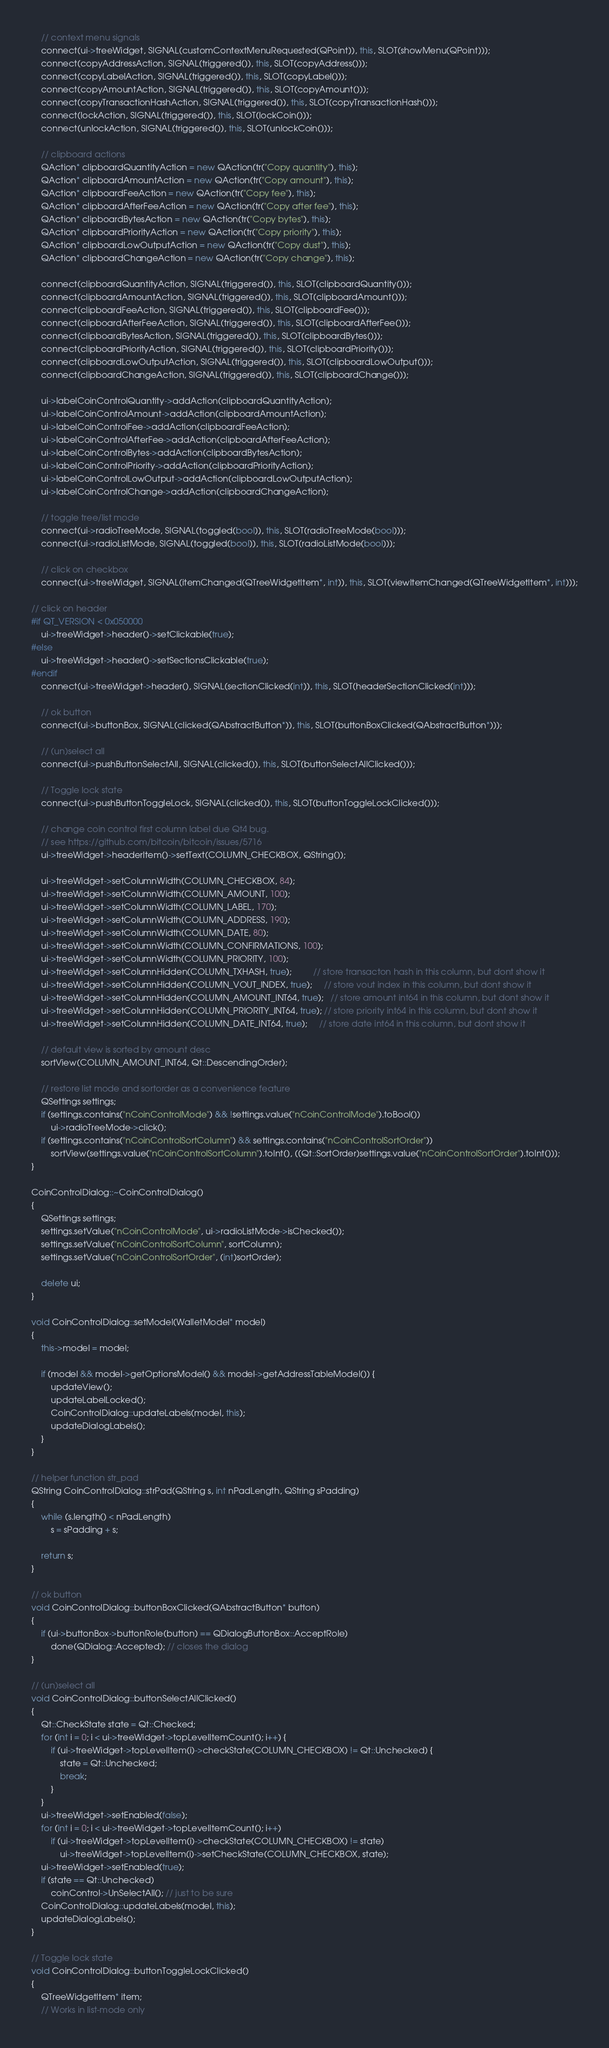Convert code to text. <code><loc_0><loc_0><loc_500><loc_500><_C++_>
    // context menu signals
    connect(ui->treeWidget, SIGNAL(customContextMenuRequested(QPoint)), this, SLOT(showMenu(QPoint)));
    connect(copyAddressAction, SIGNAL(triggered()), this, SLOT(copyAddress()));
    connect(copyLabelAction, SIGNAL(triggered()), this, SLOT(copyLabel()));
    connect(copyAmountAction, SIGNAL(triggered()), this, SLOT(copyAmount()));
    connect(copyTransactionHashAction, SIGNAL(triggered()), this, SLOT(copyTransactionHash()));
    connect(lockAction, SIGNAL(triggered()), this, SLOT(lockCoin()));
    connect(unlockAction, SIGNAL(triggered()), this, SLOT(unlockCoin()));

    // clipboard actions
    QAction* clipboardQuantityAction = new QAction(tr("Copy quantity"), this);
    QAction* clipboardAmountAction = new QAction(tr("Copy amount"), this);
    QAction* clipboardFeeAction = new QAction(tr("Copy fee"), this);
    QAction* clipboardAfterFeeAction = new QAction(tr("Copy after fee"), this);
    QAction* clipboardBytesAction = new QAction(tr("Copy bytes"), this);
    QAction* clipboardPriorityAction = new QAction(tr("Copy priority"), this);
    QAction* clipboardLowOutputAction = new QAction(tr("Copy dust"), this);
    QAction* clipboardChangeAction = new QAction(tr("Copy change"), this);

    connect(clipboardQuantityAction, SIGNAL(triggered()), this, SLOT(clipboardQuantity()));
    connect(clipboardAmountAction, SIGNAL(triggered()), this, SLOT(clipboardAmount()));
    connect(clipboardFeeAction, SIGNAL(triggered()), this, SLOT(clipboardFee()));
    connect(clipboardAfterFeeAction, SIGNAL(triggered()), this, SLOT(clipboardAfterFee()));
    connect(clipboardBytesAction, SIGNAL(triggered()), this, SLOT(clipboardBytes()));
    connect(clipboardPriorityAction, SIGNAL(triggered()), this, SLOT(clipboardPriority()));
    connect(clipboardLowOutputAction, SIGNAL(triggered()), this, SLOT(clipboardLowOutput()));
    connect(clipboardChangeAction, SIGNAL(triggered()), this, SLOT(clipboardChange()));

    ui->labelCoinControlQuantity->addAction(clipboardQuantityAction);
    ui->labelCoinControlAmount->addAction(clipboardAmountAction);
    ui->labelCoinControlFee->addAction(clipboardFeeAction);
    ui->labelCoinControlAfterFee->addAction(clipboardAfterFeeAction);
    ui->labelCoinControlBytes->addAction(clipboardBytesAction);
    ui->labelCoinControlPriority->addAction(clipboardPriorityAction);
    ui->labelCoinControlLowOutput->addAction(clipboardLowOutputAction);
    ui->labelCoinControlChange->addAction(clipboardChangeAction);

    // toggle tree/list mode
    connect(ui->radioTreeMode, SIGNAL(toggled(bool)), this, SLOT(radioTreeMode(bool)));
    connect(ui->radioListMode, SIGNAL(toggled(bool)), this, SLOT(radioListMode(bool)));

    // click on checkbox
    connect(ui->treeWidget, SIGNAL(itemChanged(QTreeWidgetItem*, int)), this, SLOT(viewItemChanged(QTreeWidgetItem*, int)));

// click on header
#if QT_VERSION < 0x050000
    ui->treeWidget->header()->setClickable(true);
#else
    ui->treeWidget->header()->setSectionsClickable(true);
#endif
    connect(ui->treeWidget->header(), SIGNAL(sectionClicked(int)), this, SLOT(headerSectionClicked(int)));

    // ok button
    connect(ui->buttonBox, SIGNAL(clicked(QAbstractButton*)), this, SLOT(buttonBoxClicked(QAbstractButton*)));

    // (un)select all
    connect(ui->pushButtonSelectAll, SIGNAL(clicked()), this, SLOT(buttonSelectAllClicked()));

    // Toggle lock state
    connect(ui->pushButtonToggleLock, SIGNAL(clicked()), this, SLOT(buttonToggleLockClicked()));

    // change coin control first column label due Qt4 bug.
    // see https://github.com/bitcoin/bitcoin/issues/5716
    ui->treeWidget->headerItem()->setText(COLUMN_CHECKBOX, QString());

    ui->treeWidget->setColumnWidth(COLUMN_CHECKBOX, 84);
    ui->treeWidget->setColumnWidth(COLUMN_AMOUNT, 100);
    ui->treeWidget->setColumnWidth(COLUMN_LABEL, 170);
    ui->treeWidget->setColumnWidth(COLUMN_ADDRESS, 190);
    ui->treeWidget->setColumnWidth(COLUMN_DATE, 80);
    ui->treeWidget->setColumnWidth(COLUMN_CONFIRMATIONS, 100);
    ui->treeWidget->setColumnWidth(COLUMN_PRIORITY, 100);
    ui->treeWidget->setColumnHidden(COLUMN_TXHASH, true);         // store transacton hash in this column, but dont show it
    ui->treeWidget->setColumnHidden(COLUMN_VOUT_INDEX, true);     // store vout index in this column, but dont show it
    ui->treeWidget->setColumnHidden(COLUMN_AMOUNT_INT64, true);   // store amount int64 in this column, but dont show it
    ui->treeWidget->setColumnHidden(COLUMN_PRIORITY_INT64, true); // store priority int64 in this column, but dont show it
    ui->treeWidget->setColumnHidden(COLUMN_DATE_INT64, true);     // store date int64 in this column, but dont show it

    // default view is sorted by amount desc
    sortView(COLUMN_AMOUNT_INT64, Qt::DescendingOrder);

    // restore list mode and sortorder as a convenience feature
    QSettings settings;
    if (settings.contains("nCoinControlMode") && !settings.value("nCoinControlMode").toBool())
        ui->radioTreeMode->click();
    if (settings.contains("nCoinControlSortColumn") && settings.contains("nCoinControlSortOrder"))
        sortView(settings.value("nCoinControlSortColumn").toInt(), ((Qt::SortOrder)settings.value("nCoinControlSortOrder").toInt()));
}

CoinControlDialog::~CoinControlDialog()
{
    QSettings settings;
    settings.setValue("nCoinControlMode", ui->radioListMode->isChecked());
    settings.setValue("nCoinControlSortColumn", sortColumn);
    settings.setValue("nCoinControlSortOrder", (int)sortOrder);

    delete ui;
}

void CoinControlDialog::setModel(WalletModel* model)
{
    this->model = model;

    if (model && model->getOptionsModel() && model->getAddressTableModel()) {
        updateView();
        updateLabelLocked();
        CoinControlDialog::updateLabels(model, this);
        updateDialogLabels();
    }
}

// helper function str_pad
QString CoinControlDialog::strPad(QString s, int nPadLength, QString sPadding)
{
    while (s.length() < nPadLength)
        s = sPadding + s;

    return s;
}

// ok button
void CoinControlDialog::buttonBoxClicked(QAbstractButton* button)
{
    if (ui->buttonBox->buttonRole(button) == QDialogButtonBox::AcceptRole)
        done(QDialog::Accepted); // closes the dialog
}

// (un)select all
void CoinControlDialog::buttonSelectAllClicked()
{
    Qt::CheckState state = Qt::Checked;
    for (int i = 0; i < ui->treeWidget->topLevelItemCount(); i++) {
        if (ui->treeWidget->topLevelItem(i)->checkState(COLUMN_CHECKBOX) != Qt::Unchecked) {
            state = Qt::Unchecked;
            break;
        }
    }
    ui->treeWidget->setEnabled(false);
    for (int i = 0; i < ui->treeWidget->topLevelItemCount(); i++)
        if (ui->treeWidget->topLevelItem(i)->checkState(COLUMN_CHECKBOX) != state)
            ui->treeWidget->topLevelItem(i)->setCheckState(COLUMN_CHECKBOX, state);
    ui->treeWidget->setEnabled(true);
    if (state == Qt::Unchecked)
        coinControl->UnSelectAll(); // just to be sure
    CoinControlDialog::updateLabels(model, this);
    updateDialogLabels();
}

// Toggle lock state
void CoinControlDialog::buttonToggleLockClicked()
{
    QTreeWidgetItem* item;
    // Works in list-mode only</code> 